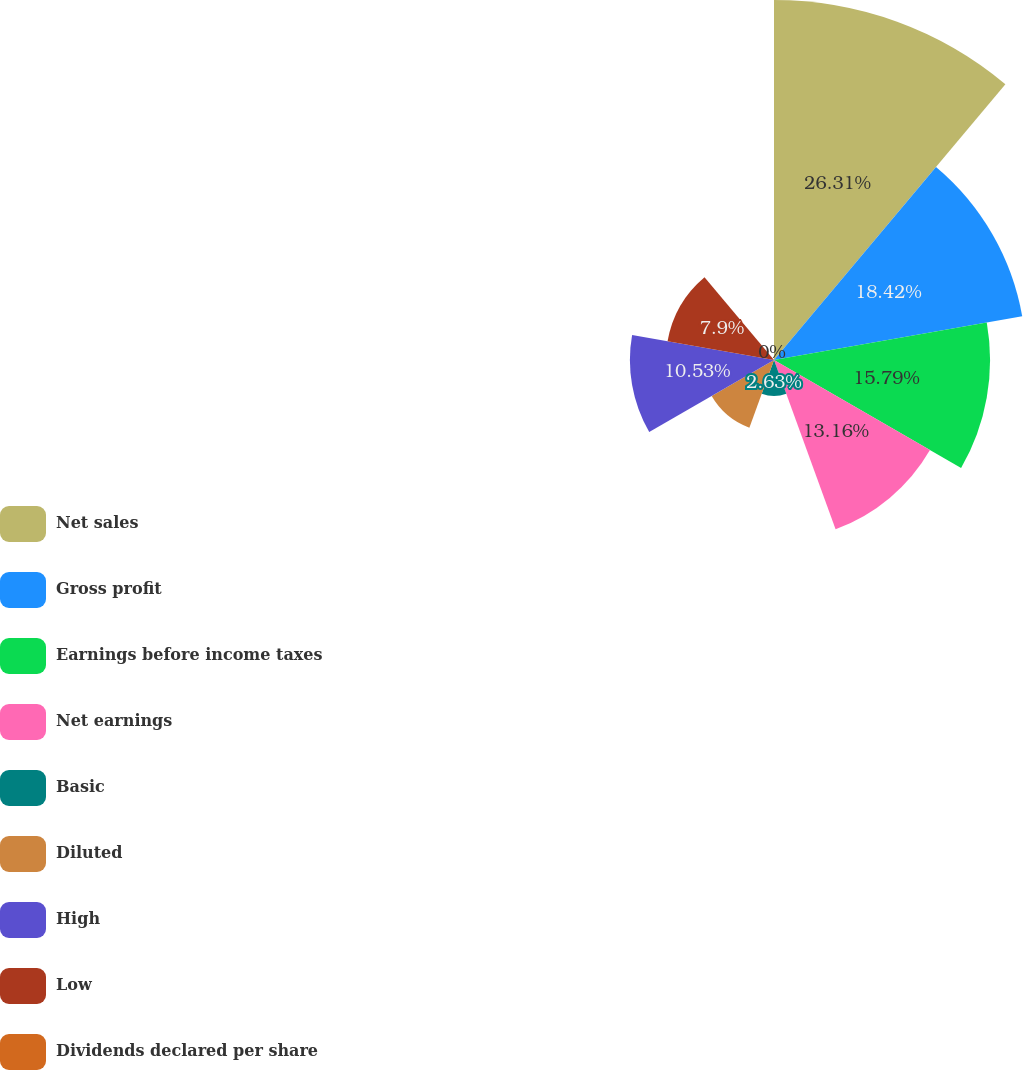Convert chart to OTSL. <chart><loc_0><loc_0><loc_500><loc_500><pie_chart><fcel>Net sales<fcel>Gross profit<fcel>Earnings before income taxes<fcel>Net earnings<fcel>Basic<fcel>Diluted<fcel>High<fcel>Low<fcel>Dividends declared per share<nl><fcel>26.31%<fcel>18.42%<fcel>15.79%<fcel>13.16%<fcel>2.63%<fcel>5.26%<fcel>10.53%<fcel>7.9%<fcel>0.0%<nl></chart> 